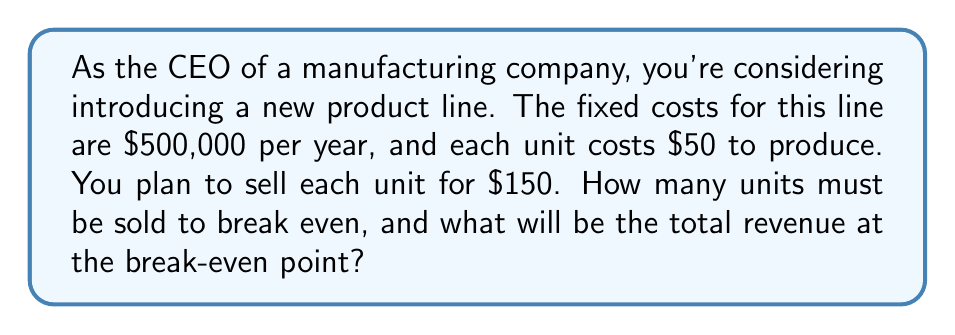Teach me how to tackle this problem. Let's approach this step-by-step:

1) Define variables:
   Let $x$ = number of units sold
   Let $y$ = total revenue

2) Set up the revenue equation:
   Revenue = Price per unit × Number of units
   $y = 150x$

3) Set up the cost equation:
   Total Cost = Fixed Costs + (Variable Cost per unit × Number of units)
   $TC = 500,000 + 50x$

4) At the break-even point, revenue equals total cost:
   $y = TC$
   $150x = 500,000 + 50x$

5) Solve for $x$:
   $150x - 50x = 500,000$
   $100x = 500,000$
   $x = 5,000$ units

6) Calculate the revenue at the break-even point:
   $y = 150 * 5,000 = 750,000$

Therefore, the company needs to sell 5,000 units to break even, and the total revenue at this point will be $750,000.
Answer: 5,000 units; $750,000 revenue 